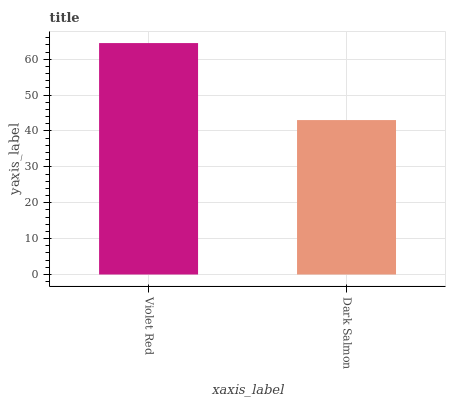Is Dark Salmon the minimum?
Answer yes or no. Yes. Is Violet Red the maximum?
Answer yes or no. Yes. Is Dark Salmon the maximum?
Answer yes or no. No. Is Violet Red greater than Dark Salmon?
Answer yes or no. Yes. Is Dark Salmon less than Violet Red?
Answer yes or no. Yes. Is Dark Salmon greater than Violet Red?
Answer yes or no. No. Is Violet Red less than Dark Salmon?
Answer yes or no. No. Is Violet Red the high median?
Answer yes or no. Yes. Is Dark Salmon the low median?
Answer yes or no. Yes. Is Dark Salmon the high median?
Answer yes or no. No. Is Violet Red the low median?
Answer yes or no. No. 